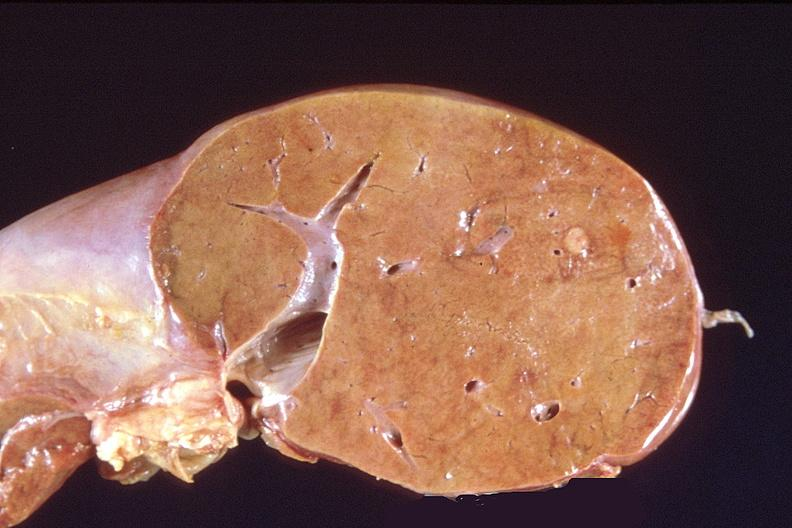s hepatobiliary present?
Answer the question using a single word or phrase. Yes 